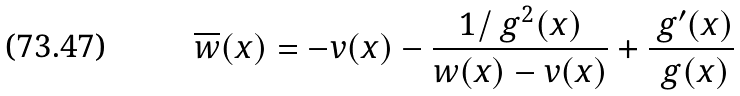Convert formula to latex. <formula><loc_0><loc_0><loc_500><loc_500>\overline { w } ( x ) = - v ( x ) - \frac { 1 / \ g ^ { 2 } ( x ) } { w ( x ) - v ( x ) } + \frac { \ g ^ { \prime } ( x ) } { \ g ( x ) }</formula> 